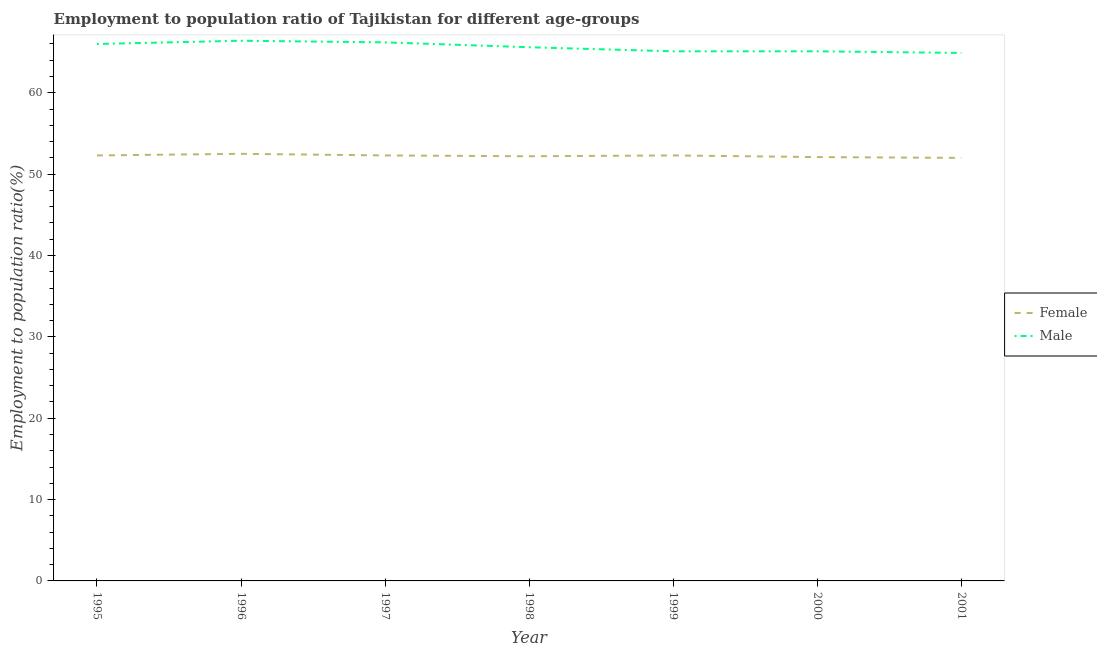What is the employment to population ratio(female) in 2000?
Ensure brevity in your answer.  52.1. Across all years, what is the maximum employment to population ratio(male)?
Give a very brief answer. 66.4. In which year was the employment to population ratio(female) maximum?
Keep it short and to the point. 1996. What is the total employment to population ratio(female) in the graph?
Provide a short and direct response. 365.7. What is the difference between the employment to population ratio(male) in 1999 and that in 2001?
Keep it short and to the point. 0.2. What is the difference between the employment to population ratio(male) in 1995 and the employment to population ratio(female) in 2000?
Keep it short and to the point. 13.9. What is the average employment to population ratio(male) per year?
Your response must be concise. 65.61. In the year 1995, what is the difference between the employment to population ratio(male) and employment to population ratio(female)?
Offer a very short reply. 13.7. What is the ratio of the employment to population ratio(male) in 2000 to that in 2001?
Provide a short and direct response. 1. Is the employment to population ratio(male) in 1999 less than that in 2000?
Make the answer very short. No. Is the difference between the employment to population ratio(male) in 1999 and 2001 greater than the difference between the employment to population ratio(female) in 1999 and 2001?
Offer a very short reply. No. What is the difference between the highest and the second highest employment to population ratio(male)?
Your answer should be compact. 0.2. Does the employment to population ratio(male) monotonically increase over the years?
Your response must be concise. No. Is the employment to population ratio(male) strictly greater than the employment to population ratio(female) over the years?
Provide a succinct answer. Yes. How many lines are there?
Keep it short and to the point. 2. What is the difference between two consecutive major ticks on the Y-axis?
Keep it short and to the point. 10. Does the graph contain any zero values?
Give a very brief answer. No. How are the legend labels stacked?
Keep it short and to the point. Vertical. What is the title of the graph?
Your response must be concise. Employment to population ratio of Tajikistan for different age-groups. Does "% of GNI" appear as one of the legend labels in the graph?
Provide a succinct answer. No. What is the label or title of the X-axis?
Make the answer very short. Year. What is the label or title of the Y-axis?
Make the answer very short. Employment to population ratio(%). What is the Employment to population ratio(%) of Female in 1995?
Give a very brief answer. 52.3. What is the Employment to population ratio(%) in Male in 1995?
Offer a very short reply. 66. What is the Employment to population ratio(%) of Female in 1996?
Your answer should be very brief. 52.5. What is the Employment to population ratio(%) of Male in 1996?
Provide a short and direct response. 66.4. What is the Employment to population ratio(%) of Female in 1997?
Offer a terse response. 52.3. What is the Employment to population ratio(%) in Male in 1997?
Keep it short and to the point. 66.2. What is the Employment to population ratio(%) in Female in 1998?
Your answer should be very brief. 52.2. What is the Employment to population ratio(%) of Male in 1998?
Your answer should be very brief. 65.6. What is the Employment to population ratio(%) in Female in 1999?
Keep it short and to the point. 52.3. What is the Employment to population ratio(%) of Male in 1999?
Make the answer very short. 65.1. What is the Employment to population ratio(%) of Female in 2000?
Your answer should be compact. 52.1. What is the Employment to population ratio(%) in Male in 2000?
Give a very brief answer. 65.1. What is the Employment to population ratio(%) in Female in 2001?
Your answer should be very brief. 52. What is the Employment to population ratio(%) in Male in 2001?
Your response must be concise. 64.9. Across all years, what is the maximum Employment to population ratio(%) of Female?
Give a very brief answer. 52.5. Across all years, what is the maximum Employment to population ratio(%) in Male?
Make the answer very short. 66.4. Across all years, what is the minimum Employment to population ratio(%) of Male?
Provide a succinct answer. 64.9. What is the total Employment to population ratio(%) in Female in the graph?
Ensure brevity in your answer.  365.7. What is the total Employment to population ratio(%) in Male in the graph?
Offer a terse response. 459.3. What is the difference between the Employment to population ratio(%) of Female in 1995 and that in 1996?
Provide a succinct answer. -0.2. What is the difference between the Employment to population ratio(%) of Female in 1995 and that in 1997?
Your answer should be very brief. 0. What is the difference between the Employment to population ratio(%) in Male in 1995 and that in 1997?
Offer a terse response. -0.2. What is the difference between the Employment to population ratio(%) of Female in 1995 and that in 1999?
Make the answer very short. 0. What is the difference between the Employment to population ratio(%) of Male in 1995 and that in 1999?
Your answer should be very brief. 0.9. What is the difference between the Employment to population ratio(%) of Female in 1995 and that in 2001?
Provide a succinct answer. 0.3. What is the difference between the Employment to population ratio(%) of Male in 1996 and that in 1997?
Make the answer very short. 0.2. What is the difference between the Employment to population ratio(%) of Female in 1996 and that in 1998?
Provide a short and direct response. 0.3. What is the difference between the Employment to population ratio(%) of Male in 1996 and that in 1998?
Ensure brevity in your answer.  0.8. What is the difference between the Employment to population ratio(%) in Female in 1996 and that in 1999?
Keep it short and to the point. 0.2. What is the difference between the Employment to population ratio(%) in Male in 1996 and that in 1999?
Make the answer very short. 1.3. What is the difference between the Employment to population ratio(%) of Female in 1996 and that in 2001?
Your answer should be compact. 0.5. What is the difference between the Employment to population ratio(%) of Male in 1996 and that in 2001?
Give a very brief answer. 1.5. What is the difference between the Employment to population ratio(%) in Female in 1997 and that in 1998?
Your answer should be compact. 0.1. What is the difference between the Employment to population ratio(%) of Female in 1997 and that in 1999?
Keep it short and to the point. 0. What is the difference between the Employment to population ratio(%) of Male in 1997 and that in 1999?
Ensure brevity in your answer.  1.1. What is the difference between the Employment to population ratio(%) of Female in 1997 and that in 2001?
Offer a very short reply. 0.3. What is the difference between the Employment to population ratio(%) of Male in 1997 and that in 2001?
Ensure brevity in your answer.  1.3. What is the difference between the Employment to population ratio(%) of Male in 1998 and that in 1999?
Offer a terse response. 0.5. What is the difference between the Employment to population ratio(%) of Female in 1998 and that in 2000?
Your answer should be very brief. 0.1. What is the difference between the Employment to population ratio(%) of Female in 1998 and that in 2001?
Your response must be concise. 0.2. What is the difference between the Employment to population ratio(%) of Female in 1999 and that in 2000?
Offer a very short reply. 0.2. What is the difference between the Employment to population ratio(%) in Female in 1999 and that in 2001?
Provide a succinct answer. 0.3. What is the difference between the Employment to population ratio(%) of Female in 2000 and that in 2001?
Ensure brevity in your answer.  0.1. What is the difference between the Employment to population ratio(%) of Male in 2000 and that in 2001?
Keep it short and to the point. 0.2. What is the difference between the Employment to population ratio(%) in Female in 1995 and the Employment to population ratio(%) in Male in 1996?
Ensure brevity in your answer.  -14.1. What is the difference between the Employment to population ratio(%) of Female in 1995 and the Employment to population ratio(%) of Male in 1998?
Give a very brief answer. -13.3. What is the difference between the Employment to population ratio(%) in Female in 1995 and the Employment to population ratio(%) in Male in 2000?
Give a very brief answer. -12.8. What is the difference between the Employment to population ratio(%) of Female in 1995 and the Employment to population ratio(%) of Male in 2001?
Provide a short and direct response. -12.6. What is the difference between the Employment to population ratio(%) of Female in 1996 and the Employment to population ratio(%) of Male in 1997?
Keep it short and to the point. -13.7. What is the difference between the Employment to population ratio(%) in Female in 1996 and the Employment to population ratio(%) in Male in 1998?
Offer a terse response. -13.1. What is the difference between the Employment to population ratio(%) of Female in 1996 and the Employment to population ratio(%) of Male in 2001?
Provide a short and direct response. -12.4. What is the difference between the Employment to population ratio(%) in Female in 1997 and the Employment to population ratio(%) in Male in 1998?
Ensure brevity in your answer.  -13.3. What is the difference between the Employment to population ratio(%) of Female in 1997 and the Employment to population ratio(%) of Male in 2001?
Give a very brief answer. -12.6. What is the difference between the Employment to population ratio(%) in Female in 1998 and the Employment to population ratio(%) in Male in 1999?
Offer a terse response. -12.9. What is the difference between the Employment to population ratio(%) in Female in 1998 and the Employment to population ratio(%) in Male in 2000?
Make the answer very short. -12.9. What is the difference between the Employment to population ratio(%) in Female in 1999 and the Employment to population ratio(%) in Male in 2000?
Your answer should be compact. -12.8. What is the difference between the Employment to population ratio(%) of Female in 1999 and the Employment to population ratio(%) of Male in 2001?
Your answer should be compact. -12.6. What is the average Employment to population ratio(%) in Female per year?
Provide a succinct answer. 52.24. What is the average Employment to population ratio(%) in Male per year?
Offer a very short reply. 65.61. In the year 1995, what is the difference between the Employment to population ratio(%) in Female and Employment to population ratio(%) in Male?
Your answer should be very brief. -13.7. In the year 1996, what is the difference between the Employment to population ratio(%) in Female and Employment to population ratio(%) in Male?
Provide a succinct answer. -13.9. In the year 1999, what is the difference between the Employment to population ratio(%) of Female and Employment to population ratio(%) of Male?
Give a very brief answer. -12.8. In the year 2000, what is the difference between the Employment to population ratio(%) in Female and Employment to population ratio(%) in Male?
Keep it short and to the point. -13. What is the ratio of the Employment to population ratio(%) in Female in 1995 to that in 1998?
Provide a short and direct response. 1. What is the ratio of the Employment to population ratio(%) in Male in 1995 to that in 1998?
Offer a terse response. 1.01. What is the ratio of the Employment to population ratio(%) of Female in 1995 to that in 1999?
Your answer should be compact. 1. What is the ratio of the Employment to population ratio(%) in Male in 1995 to that in 1999?
Your response must be concise. 1.01. What is the ratio of the Employment to population ratio(%) in Female in 1995 to that in 2000?
Your response must be concise. 1. What is the ratio of the Employment to population ratio(%) in Male in 1995 to that in 2000?
Provide a short and direct response. 1.01. What is the ratio of the Employment to population ratio(%) in Male in 1995 to that in 2001?
Ensure brevity in your answer.  1.02. What is the ratio of the Employment to population ratio(%) in Male in 1996 to that in 1998?
Provide a short and direct response. 1.01. What is the ratio of the Employment to population ratio(%) of Female in 1996 to that in 1999?
Provide a succinct answer. 1. What is the ratio of the Employment to population ratio(%) of Male in 1996 to that in 1999?
Give a very brief answer. 1.02. What is the ratio of the Employment to population ratio(%) of Female in 1996 to that in 2000?
Keep it short and to the point. 1.01. What is the ratio of the Employment to population ratio(%) in Male in 1996 to that in 2000?
Give a very brief answer. 1.02. What is the ratio of the Employment to population ratio(%) in Female in 1996 to that in 2001?
Your answer should be very brief. 1.01. What is the ratio of the Employment to population ratio(%) of Male in 1996 to that in 2001?
Make the answer very short. 1.02. What is the ratio of the Employment to population ratio(%) of Male in 1997 to that in 1998?
Offer a terse response. 1.01. What is the ratio of the Employment to population ratio(%) of Male in 1997 to that in 1999?
Give a very brief answer. 1.02. What is the ratio of the Employment to population ratio(%) in Female in 1997 to that in 2000?
Your response must be concise. 1. What is the ratio of the Employment to population ratio(%) of Male in 1997 to that in 2000?
Provide a short and direct response. 1.02. What is the ratio of the Employment to population ratio(%) of Female in 1998 to that in 1999?
Provide a succinct answer. 1. What is the ratio of the Employment to population ratio(%) in Male in 1998 to that in 1999?
Offer a very short reply. 1.01. What is the ratio of the Employment to population ratio(%) in Male in 1998 to that in 2000?
Provide a succinct answer. 1.01. What is the ratio of the Employment to population ratio(%) of Male in 1998 to that in 2001?
Keep it short and to the point. 1.01. What is the ratio of the Employment to population ratio(%) of Male in 1999 to that in 2000?
Your answer should be compact. 1. What is the ratio of the Employment to population ratio(%) in Male in 1999 to that in 2001?
Provide a succinct answer. 1. What is the difference between the highest and the second highest Employment to population ratio(%) of Male?
Offer a very short reply. 0.2. What is the difference between the highest and the lowest Employment to population ratio(%) of Female?
Offer a very short reply. 0.5. 